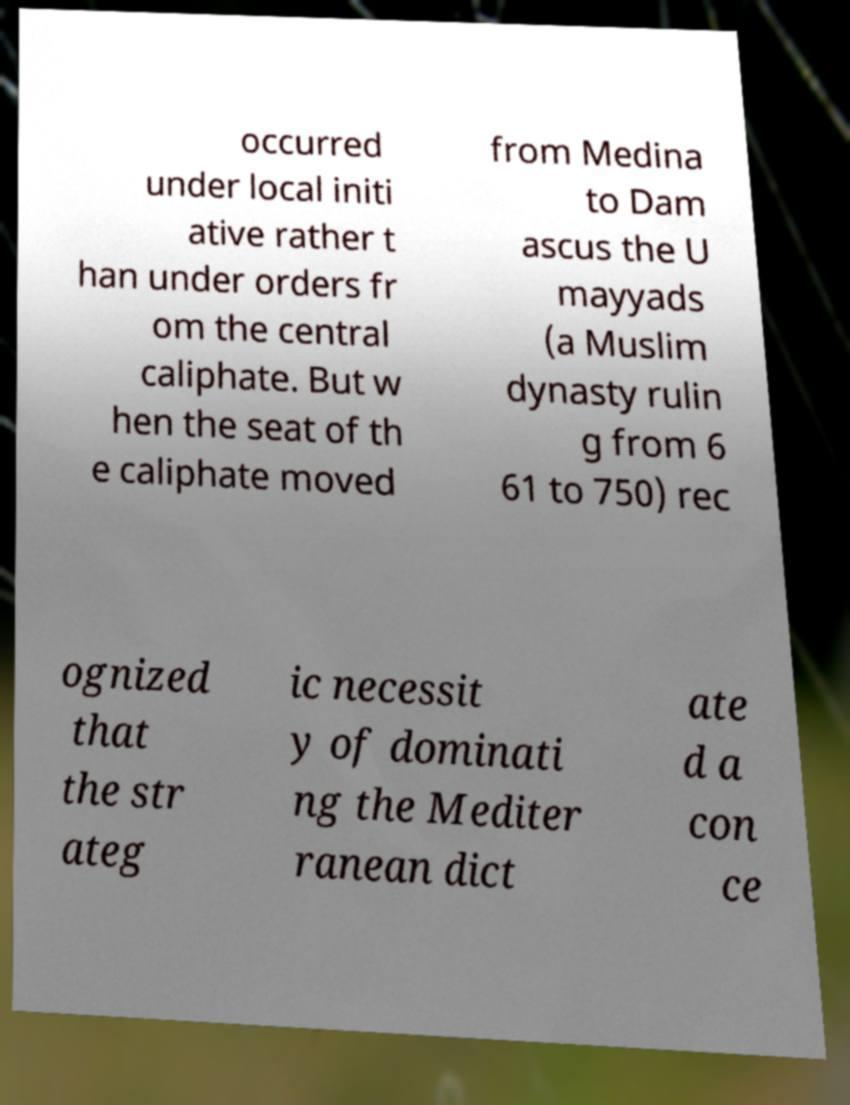Please read and relay the text visible in this image. What does it say? occurred under local initi ative rather t han under orders fr om the central caliphate. But w hen the seat of th e caliphate moved from Medina to Dam ascus the U mayyads (a Muslim dynasty rulin g from 6 61 to 750) rec ognized that the str ateg ic necessit y of dominati ng the Mediter ranean dict ate d a con ce 